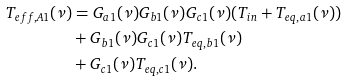Convert formula to latex. <formula><loc_0><loc_0><loc_500><loc_500>T _ { e f f , A 1 } ( \nu ) & = G _ { a 1 } ( \nu ) G _ { b 1 } ( \nu ) G _ { c 1 } ( \nu ) ( T _ { i n } + T _ { e q , a 1 } ( \nu ) ) \\ & + G _ { b 1 } ( \nu ) G _ { c 1 } ( \nu ) T _ { e q , b 1 } ( \nu ) \\ & + G _ { c 1 } ( \nu ) T _ { e q , c 1 } ( \nu ) .</formula> 